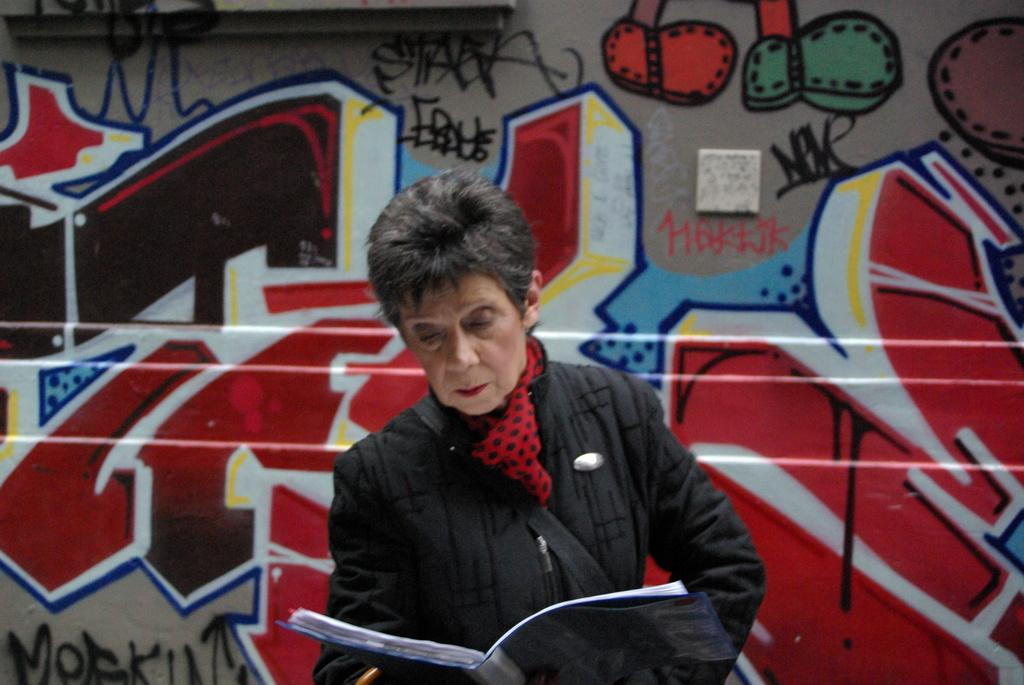Who is present in the image? There is a woman in the image. What is the woman holding in the image? The woman is holding a book. What can be seen on the wall in the background of the image? There is a painting on the wall in the background of the image. What type of cracker is the woman eating in the image? There is no cracker present in the image; the woman is holding a book. What noise can be heard coming from the houses in the image? There are no houses present in the image, so it's not possible to determine what noises might be heard. 